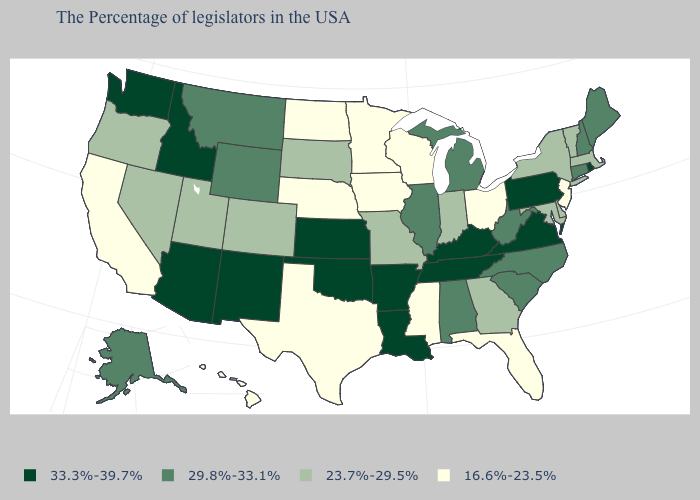What is the value of Rhode Island?
Keep it brief. 33.3%-39.7%. Name the states that have a value in the range 23.7%-29.5%?
Short answer required. Massachusetts, Vermont, New York, Delaware, Maryland, Georgia, Indiana, Missouri, South Dakota, Colorado, Utah, Nevada, Oregon. Among the states that border Delaware , which have the highest value?
Give a very brief answer. Pennsylvania. Name the states that have a value in the range 16.6%-23.5%?
Quick response, please. New Jersey, Ohio, Florida, Wisconsin, Mississippi, Minnesota, Iowa, Nebraska, Texas, North Dakota, California, Hawaii. What is the value of Arizona?
Concise answer only. 33.3%-39.7%. Name the states that have a value in the range 29.8%-33.1%?
Be succinct. Maine, New Hampshire, Connecticut, North Carolina, South Carolina, West Virginia, Michigan, Alabama, Illinois, Wyoming, Montana, Alaska. Does New Jersey have the lowest value in the USA?
Write a very short answer. Yes. Name the states that have a value in the range 23.7%-29.5%?
Answer briefly. Massachusetts, Vermont, New York, Delaware, Maryland, Georgia, Indiana, Missouri, South Dakota, Colorado, Utah, Nevada, Oregon. What is the lowest value in the USA?
Answer briefly. 16.6%-23.5%. What is the highest value in the USA?
Be succinct. 33.3%-39.7%. What is the highest value in states that border Alabama?
Concise answer only. 33.3%-39.7%. Is the legend a continuous bar?
Keep it brief. No. What is the value of Vermont?
Write a very short answer. 23.7%-29.5%. What is the value of Tennessee?
Keep it brief. 33.3%-39.7%. What is the value of Kentucky?
Keep it brief. 33.3%-39.7%. 